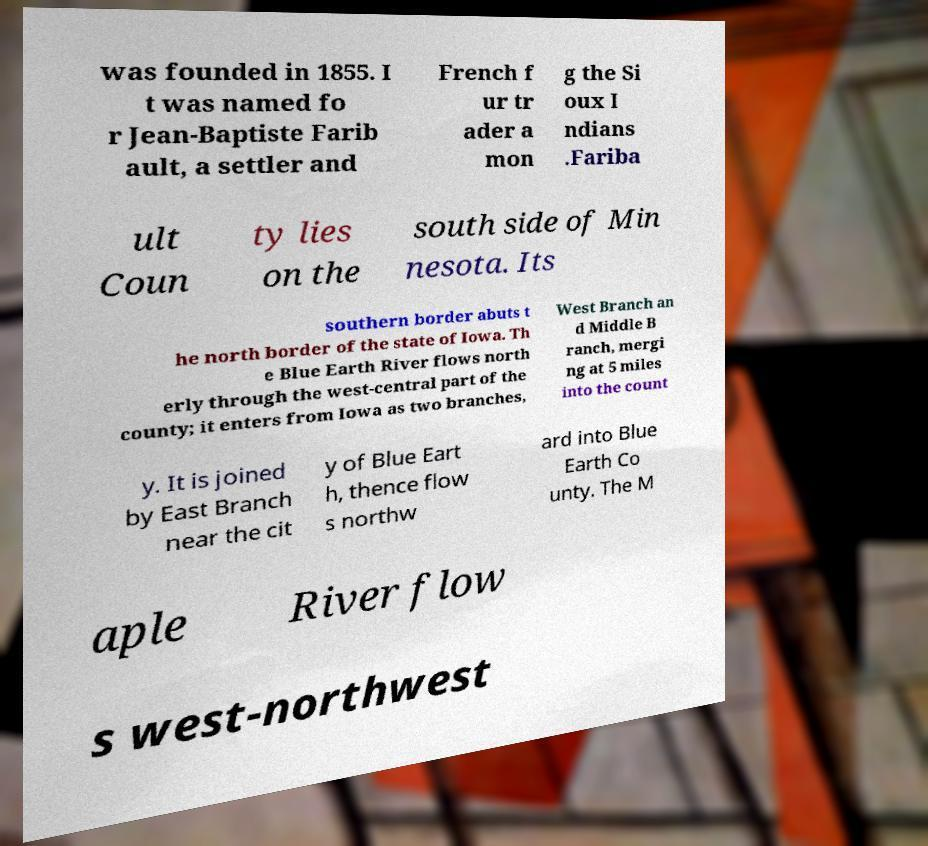For documentation purposes, I need the text within this image transcribed. Could you provide that? was founded in 1855. I t was named fo r Jean-Baptiste Farib ault, a settler and French f ur tr ader a mon g the Si oux I ndians .Fariba ult Coun ty lies on the south side of Min nesota. Its southern border abuts t he north border of the state of Iowa. Th e Blue Earth River flows north erly through the west-central part of the county; it enters from Iowa as two branches, West Branch an d Middle B ranch, mergi ng at 5 miles into the count y. It is joined by East Branch near the cit y of Blue Eart h, thence flow s northw ard into Blue Earth Co unty. The M aple River flow s west-northwest 